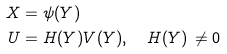Convert formula to latex. <formula><loc_0><loc_0><loc_500><loc_500>X & = \psi ( Y ) \\ U & = H ( Y ) V ( Y ) , \quad H ( Y ) \, \neq 0</formula> 